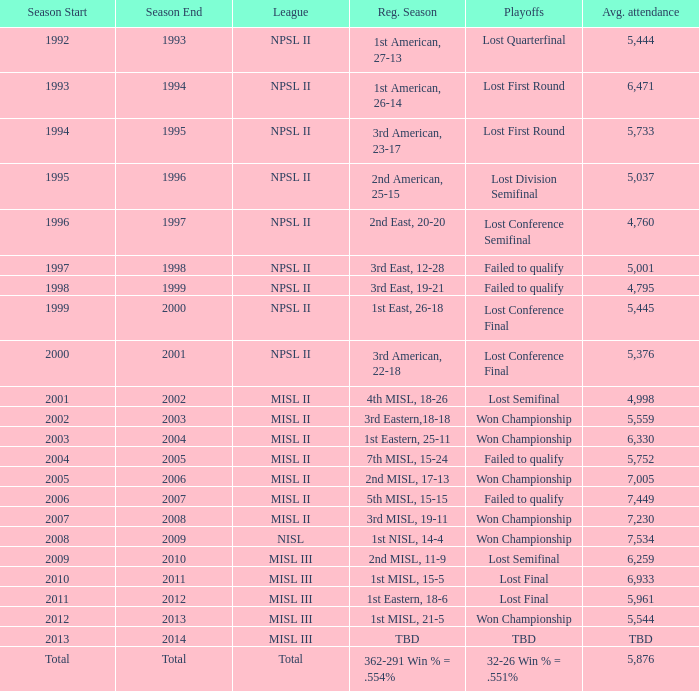In 2010-11, what was the League name? MISL III. 